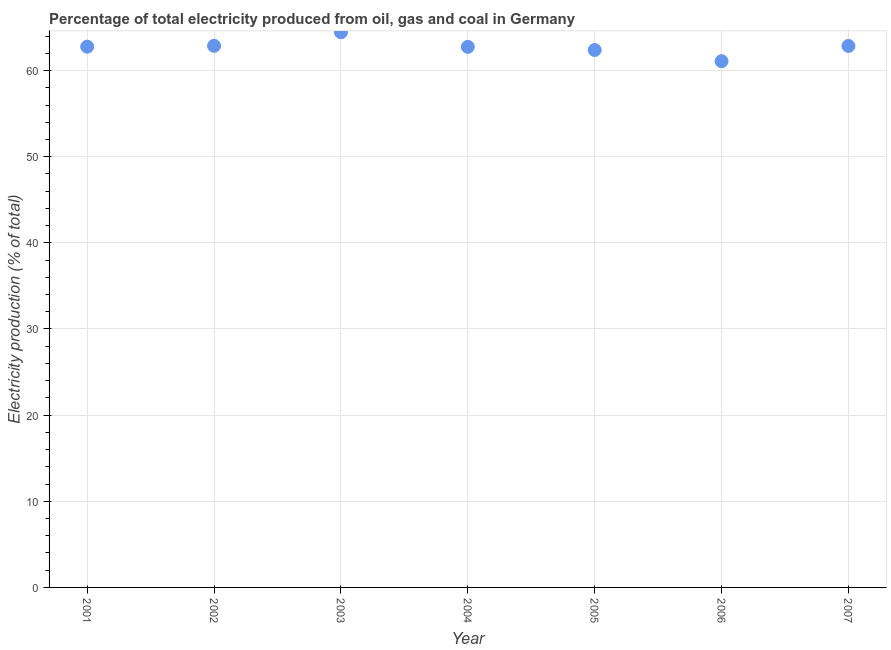What is the electricity production in 2001?
Give a very brief answer. 62.77. Across all years, what is the maximum electricity production?
Provide a succinct answer. 64.44. Across all years, what is the minimum electricity production?
Make the answer very short. 61.09. In which year was the electricity production maximum?
Offer a very short reply. 2003. In which year was the electricity production minimum?
Give a very brief answer. 2006. What is the sum of the electricity production?
Your response must be concise. 439.15. What is the difference between the electricity production in 2003 and 2006?
Make the answer very short. 3.36. What is the average electricity production per year?
Your response must be concise. 62.74. What is the median electricity production?
Your response must be concise. 62.77. What is the ratio of the electricity production in 2004 to that in 2007?
Make the answer very short. 1. Is the difference between the electricity production in 2006 and 2007 greater than the difference between any two years?
Offer a very short reply. No. What is the difference between the highest and the second highest electricity production?
Offer a terse response. 1.57. Is the sum of the electricity production in 2002 and 2003 greater than the maximum electricity production across all years?
Your answer should be compact. Yes. What is the difference between the highest and the lowest electricity production?
Keep it short and to the point. 3.36. How many dotlines are there?
Your answer should be compact. 1. How many years are there in the graph?
Your response must be concise. 7. Are the values on the major ticks of Y-axis written in scientific E-notation?
Your response must be concise. No. Does the graph contain grids?
Keep it short and to the point. Yes. What is the title of the graph?
Give a very brief answer. Percentage of total electricity produced from oil, gas and coal in Germany. What is the label or title of the X-axis?
Offer a terse response. Year. What is the label or title of the Y-axis?
Provide a short and direct response. Electricity production (% of total). What is the Electricity production (% of total) in 2001?
Offer a terse response. 62.77. What is the Electricity production (% of total) in 2002?
Your answer should be compact. 62.87. What is the Electricity production (% of total) in 2003?
Keep it short and to the point. 64.44. What is the Electricity production (% of total) in 2004?
Give a very brief answer. 62.75. What is the Electricity production (% of total) in 2005?
Give a very brief answer. 62.38. What is the Electricity production (% of total) in 2006?
Offer a terse response. 61.09. What is the Electricity production (% of total) in 2007?
Offer a very short reply. 62.86. What is the difference between the Electricity production (% of total) in 2001 and 2002?
Your response must be concise. -0.1. What is the difference between the Electricity production (% of total) in 2001 and 2003?
Your response must be concise. -1.67. What is the difference between the Electricity production (% of total) in 2001 and 2004?
Ensure brevity in your answer.  0.02. What is the difference between the Electricity production (% of total) in 2001 and 2005?
Your response must be concise. 0.39. What is the difference between the Electricity production (% of total) in 2001 and 2006?
Offer a terse response. 1.68. What is the difference between the Electricity production (% of total) in 2001 and 2007?
Keep it short and to the point. -0.09. What is the difference between the Electricity production (% of total) in 2002 and 2003?
Your response must be concise. -1.57. What is the difference between the Electricity production (% of total) in 2002 and 2004?
Your answer should be very brief. 0.12. What is the difference between the Electricity production (% of total) in 2002 and 2005?
Provide a succinct answer. 0.49. What is the difference between the Electricity production (% of total) in 2002 and 2006?
Provide a succinct answer. 1.78. What is the difference between the Electricity production (% of total) in 2002 and 2007?
Make the answer very short. 0.01. What is the difference between the Electricity production (% of total) in 2003 and 2004?
Your answer should be compact. 1.69. What is the difference between the Electricity production (% of total) in 2003 and 2005?
Offer a very short reply. 2.06. What is the difference between the Electricity production (% of total) in 2003 and 2006?
Ensure brevity in your answer.  3.36. What is the difference between the Electricity production (% of total) in 2003 and 2007?
Ensure brevity in your answer.  1.59. What is the difference between the Electricity production (% of total) in 2004 and 2005?
Ensure brevity in your answer.  0.37. What is the difference between the Electricity production (% of total) in 2004 and 2006?
Give a very brief answer. 1.66. What is the difference between the Electricity production (% of total) in 2004 and 2007?
Ensure brevity in your answer.  -0.11. What is the difference between the Electricity production (% of total) in 2005 and 2006?
Give a very brief answer. 1.3. What is the difference between the Electricity production (% of total) in 2005 and 2007?
Your response must be concise. -0.47. What is the difference between the Electricity production (% of total) in 2006 and 2007?
Provide a short and direct response. -1.77. What is the ratio of the Electricity production (% of total) in 2001 to that in 2004?
Your answer should be compact. 1. What is the ratio of the Electricity production (% of total) in 2001 to that in 2006?
Your answer should be very brief. 1.03. What is the ratio of the Electricity production (% of total) in 2001 to that in 2007?
Make the answer very short. 1. What is the ratio of the Electricity production (% of total) in 2002 to that in 2007?
Offer a very short reply. 1. What is the ratio of the Electricity production (% of total) in 2003 to that in 2005?
Ensure brevity in your answer.  1.03. What is the ratio of the Electricity production (% of total) in 2003 to that in 2006?
Your response must be concise. 1.05. What is the ratio of the Electricity production (% of total) in 2004 to that in 2005?
Ensure brevity in your answer.  1.01. What is the ratio of the Electricity production (% of total) in 2005 to that in 2007?
Make the answer very short. 0.99. 